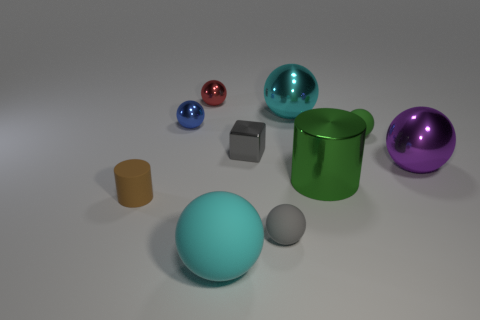Can you describe the objects in the foreground and how they compare in size and material? Certainly! In the foreground, you'll notice a sizable teal sphere with a smooth, matte finish that stands out due to its size. Close to it, there's a smaller gray sphere with a similar matte finish. The teal sphere is notably larger and emits a softness due to its material, contrasting with the reflective qualities of the metallic objects in the background. 